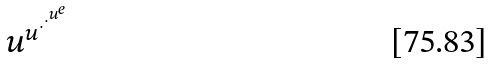Convert formula to latex. <formula><loc_0><loc_0><loc_500><loc_500>u ^ { u ^ { \cdot ^ { \cdot ^ { u ^ { e } } } } }</formula> 